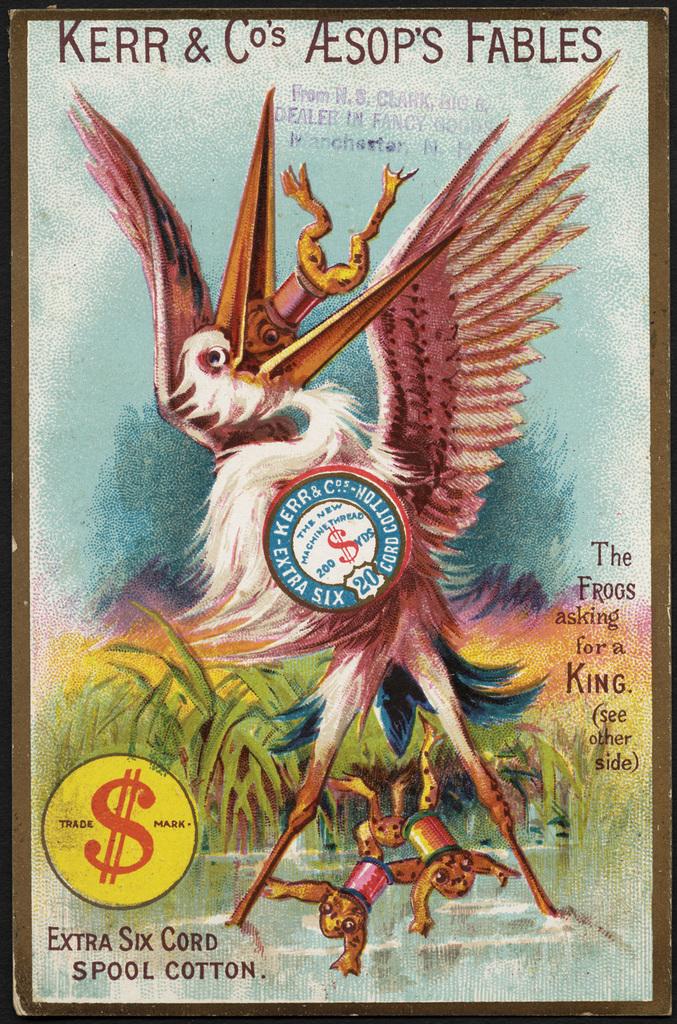Who's wrote the fables?
Offer a very short reply. Aesop. Does it mention spool cotton?
Make the answer very short. Yes. 